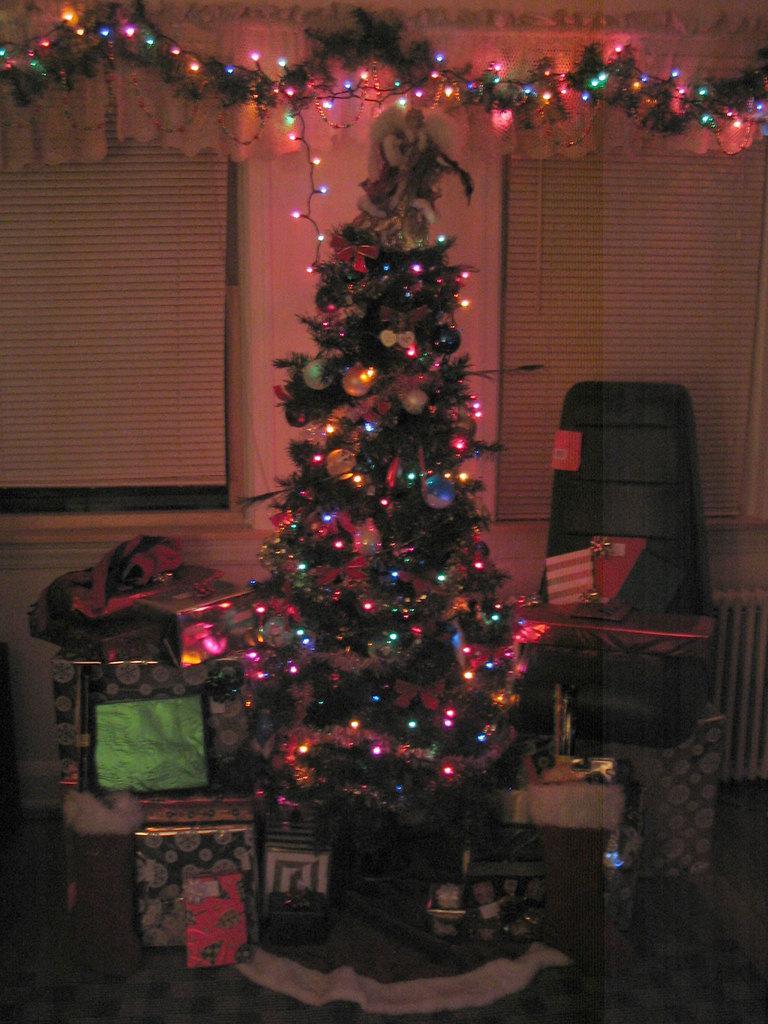Could you give a brief overview of what you see in this image? In this image there is a Christmas tree. There are fairy lights and decorative things on the Christmas tree. There are gifts around the Christmas tree. To the right there is a chair. Behind the tree there is a wall. There are window blinds on the wall. At the top there are decorative things and a cloth on the wall. 